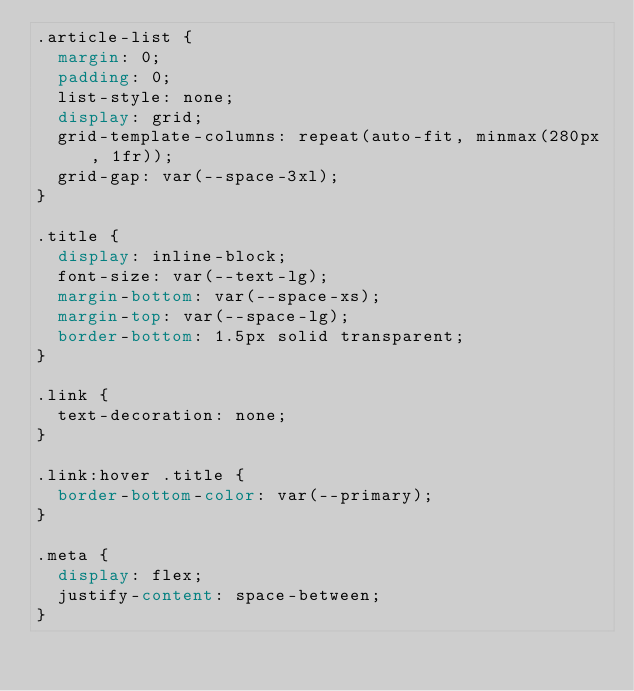Convert code to text. <code><loc_0><loc_0><loc_500><loc_500><_CSS_>.article-list {
  margin: 0;
  padding: 0;
  list-style: none;
  display: grid;
  grid-template-columns: repeat(auto-fit, minmax(280px, 1fr));
  grid-gap: var(--space-3xl);
}

.title {
  display: inline-block;
  font-size: var(--text-lg);
  margin-bottom: var(--space-xs);
  margin-top: var(--space-lg);
  border-bottom: 1.5px solid transparent;
}

.link {
  text-decoration: none;
}

.link:hover .title {
  border-bottom-color: var(--primary);
}

.meta {
  display: flex;
  justify-content: space-between;
}
</code> 